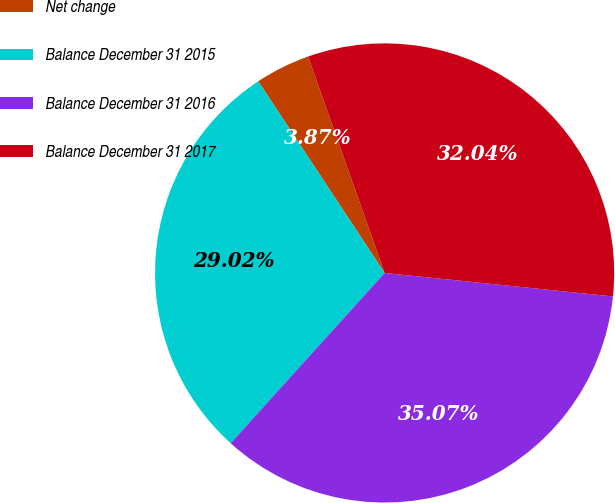Convert chart to OTSL. <chart><loc_0><loc_0><loc_500><loc_500><pie_chart><fcel>Net change<fcel>Balance December 31 2015<fcel>Balance December 31 2016<fcel>Balance December 31 2017<nl><fcel>3.87%<fcel>29.02%<fcel>35.07%<fcel>32.04%<nl></chart> 